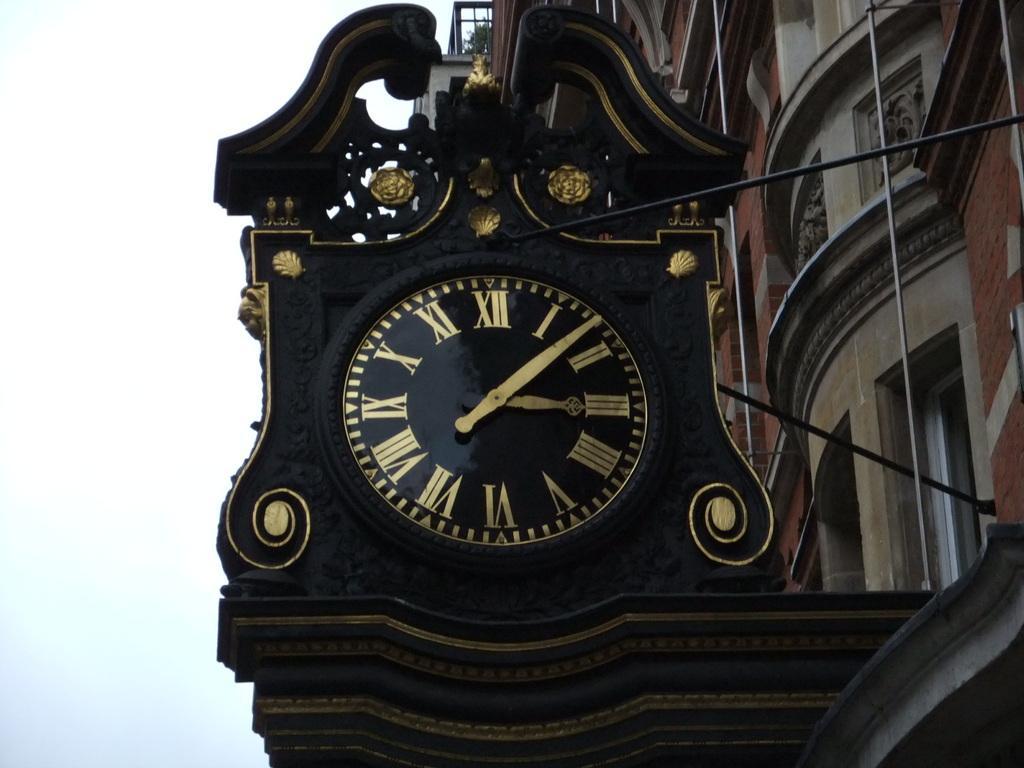In one or two sentences, can you explain what this image depicts? This is the picture of a building. In this image there is a clock on the building and at the top of the building there is a plant. At the top there is sky. 